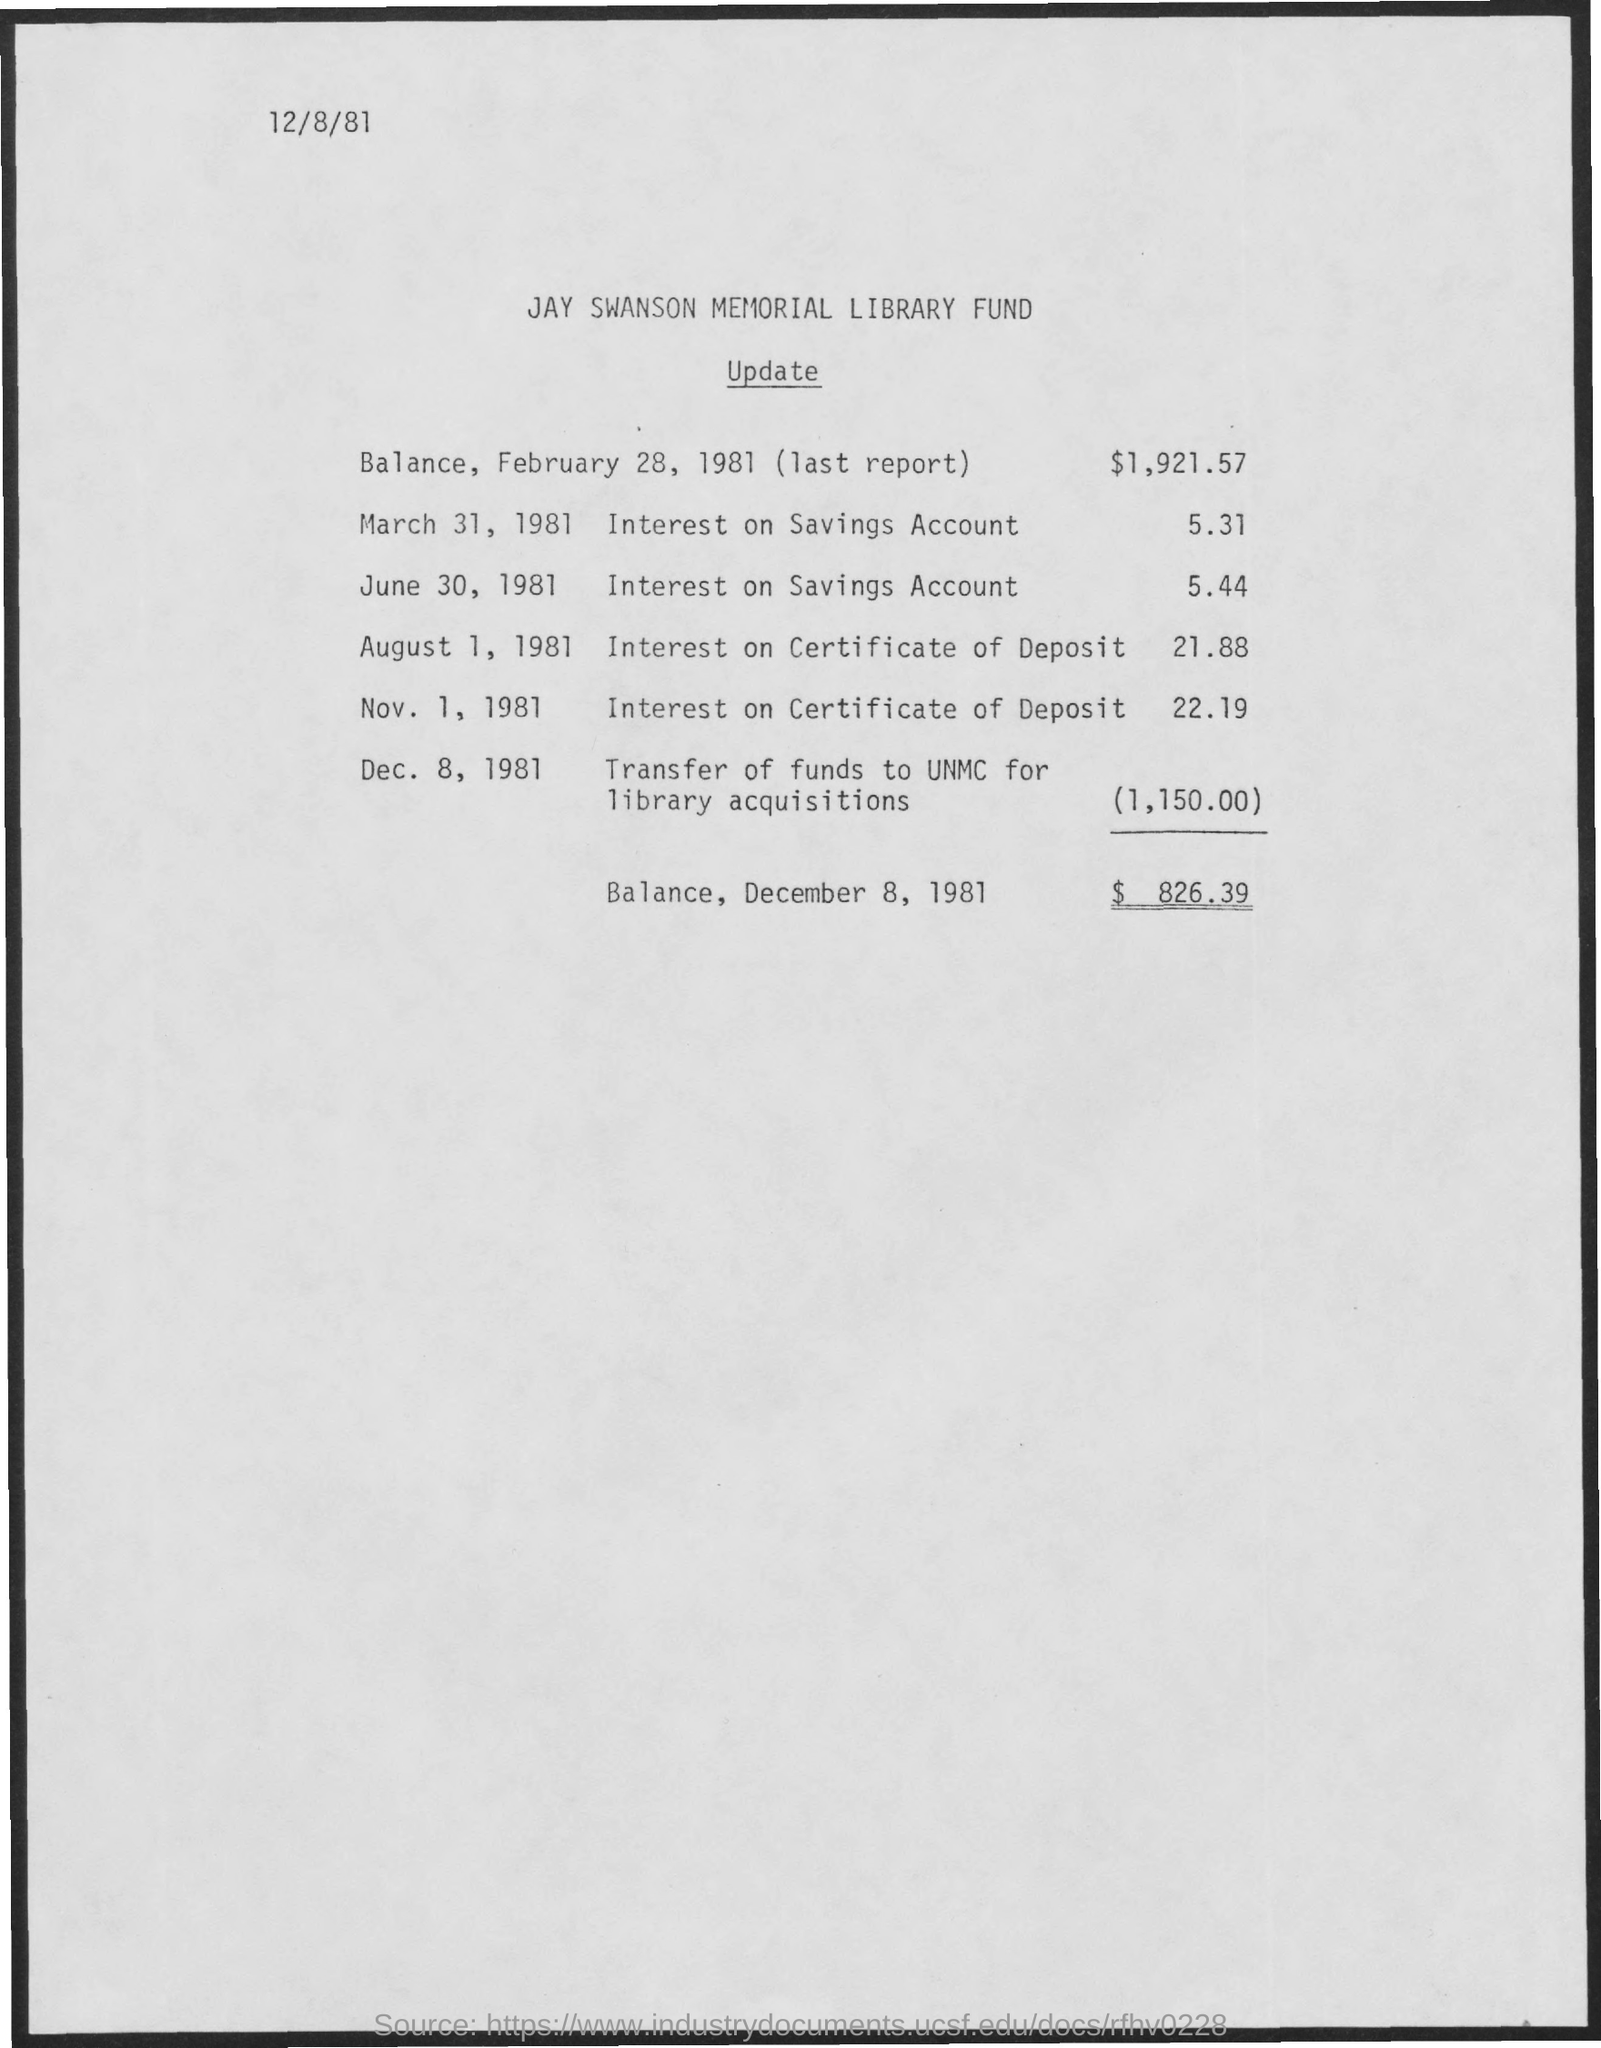Specify some key components in this picture. On December 8, 1981, the balance was 826.39 cents. The document's date of creation is December 8, 1981. On February 28, 1981, the balance was $1,921.57. 